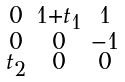<formula> <loc_0><loc_0><loc_500><loc_500>\begin{smallmatrix} 0 & 1 + t _ { 1 } & 1 \\ 0 & 0 & - 1 \\ t _ { 2 } & 0 & 0 \end{smallmatrix}</formula> 